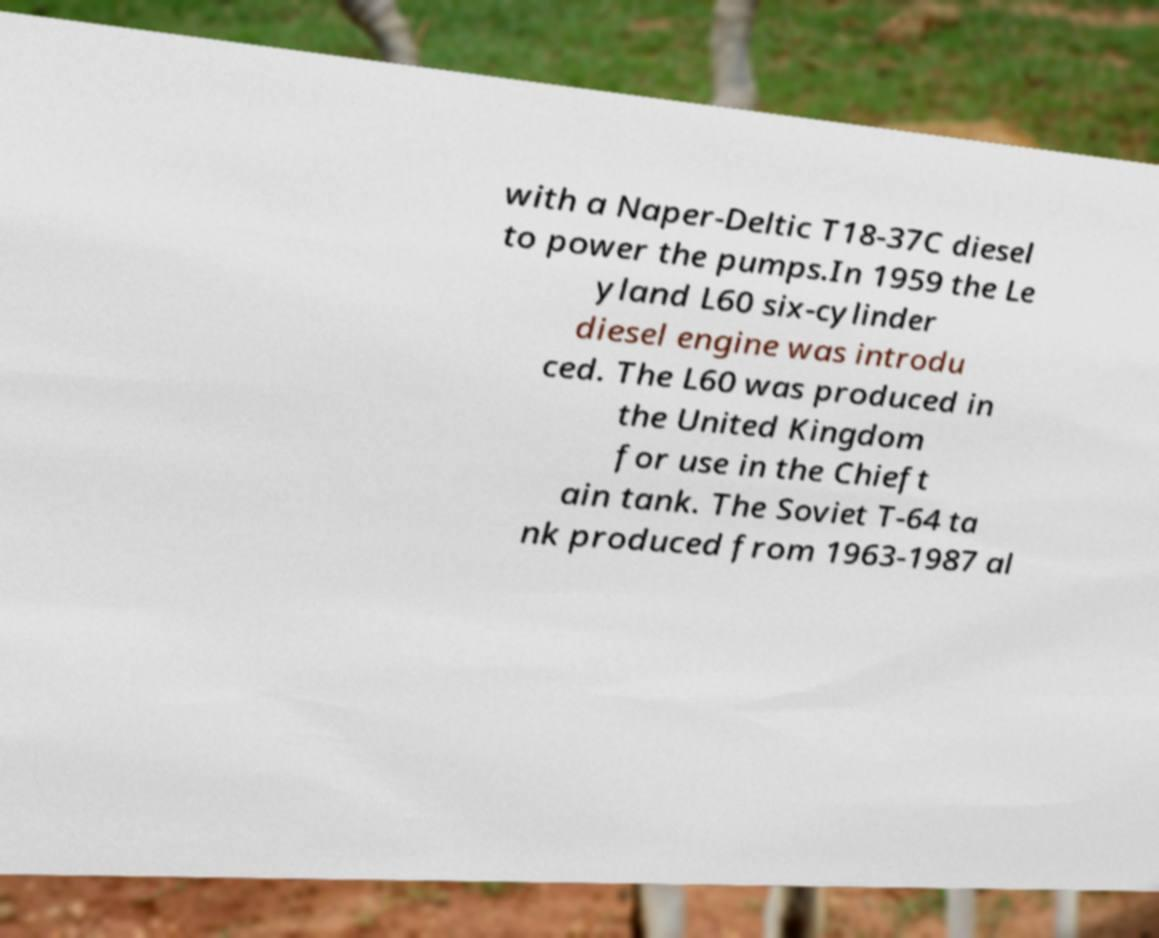There's text embedded in this image that I need extracted. Can you transcribe it verbatim? with a Naper-Deltic T18-37C diesel to power the pumps.In 1959 the Le yland L60 six-cylinder diesel engine was introdu ced. The L60 was produced in the United Kingdom for use in the Chieft ain tank. The Soviet T-64 ta nk produced from 1963-1987 al 